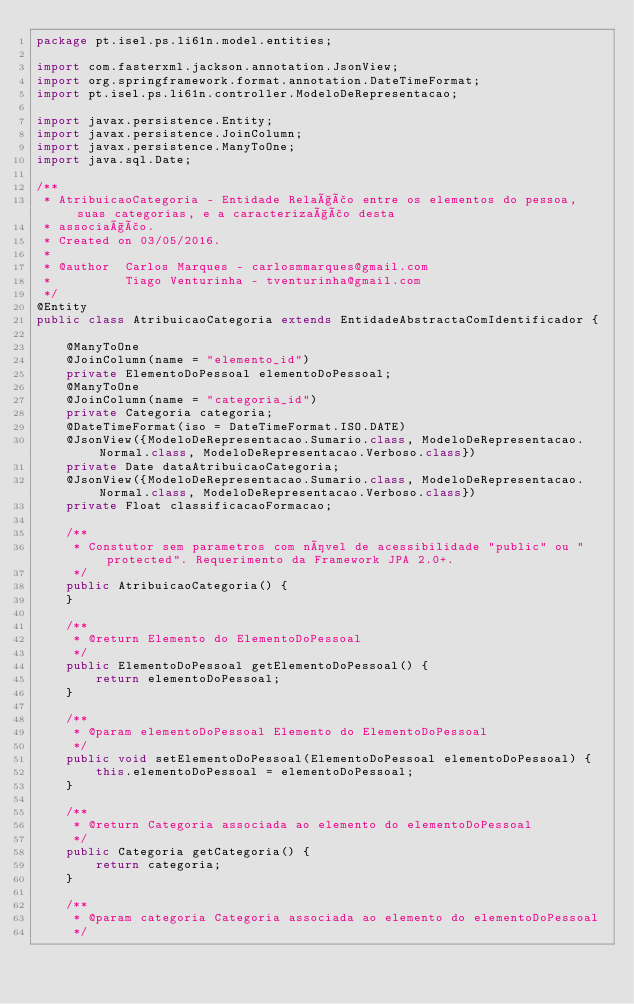<code> <loc_0><loc_0><loc_500><loc_500><_Java_>package pt.isel.ps.li61n.model.entities;

import com.fasterxml.jackson.annotation.JsonView;
import org.springframework.format.annotation.DateTimeFormat;
import pt.isel.ps.li61n.controller.ModeloDeRepresentacao;

import javax.persistence.Entity;
import javax.persistence.JoinColumn;
import javax.persistence.ManyToOne;
import java.sql.Date;

/**
 * AtribuicaoCategoria - Entidade Relação entre os elementos do pessoa, suas categorias, e a caracterização desta
 * associação.
 * Created on 03/05/2016.
 *
 * @author  Carlos Marques - carlosmmarques@gmail.com
 *          Tiago Venturinha - tventurinha@gmail.com
 */
@Entity
public class AtribuicaoCategoria extends EntidadeAbstractaComIdentificador {

    @ManyToOne
    @JoinColumn(name = "elemento_id")
    private ElementoDoPessoal elementoDoPessoal;
    @ManyToOne
    @JoinColumn(name = "categoria_id")
    private Categoria categoria;
    @DateTimeFormat(iso = DateTimeFormat.ISO.DATE)
    @JsonView({ModeloDeRepresentacao.Sumario.class, ModeloDeRepresentacao.Normal.class, ModeloDeRepresentacao.Verboso.class})
    private Date dataAtribuicaoCategoria;
    @JsonView({ModeloDeRepresentacao.Sumario.class, ModeloDeRepresentacao.Normal.class, ModeloDeRepresentacao.Verboso.class})
    private Float classificacaoFormacao;

    /**
     * Constutor sem parametros com nível de acessibilidade "public" ou "protected". Requerimento da Framework JPA 2.0+.
     */
    public AtribuicaoCategoria() {
    }

    /**
     * @return Elemento do ElementoDoPessoal
     */
    public ElementoDoPessoal getElementoDoPessoal() {
        return elementoDoPessoal;
    }

    /**
     * @param elementoDoPessoal Elemento do ElementoDoPessoal
     */
    public void setElementoDoPessoal(ElementoDoPessoal elementoDoPessoal) {
        this.elementoDoPessoal = elementoDoPessoal;
    }

    /**
     * @return Categoria associada ao elemento do elementoDoPessoal
     */
    public Categoria getCategoria() {
        return categoria;
    }

    /**
     * @param categoria Categoria associada ao elemento do elementoDoPessoal
     */</code> 